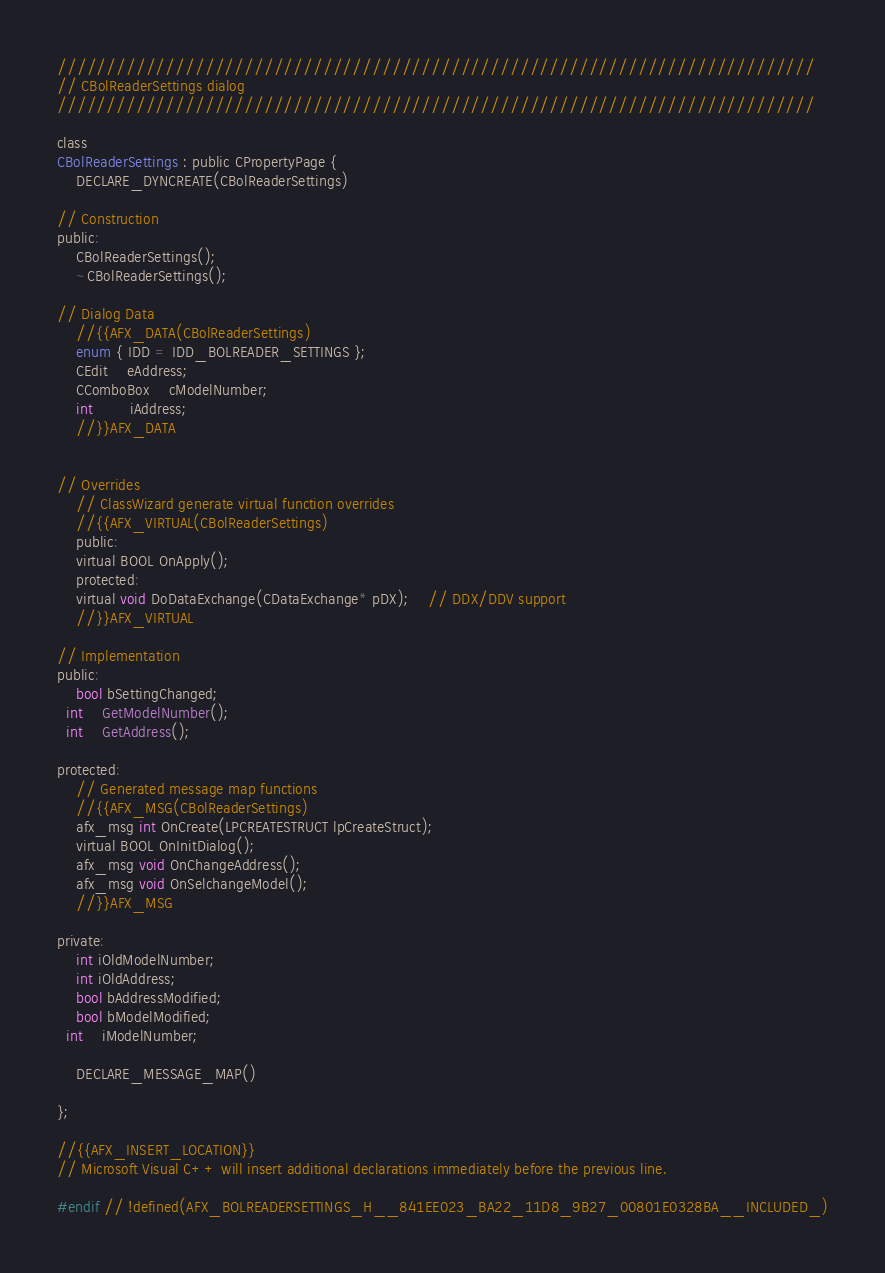Convert code to text. <code><loc_0><loc_0><loc_500><loc_500><_C_>/////////////////////////////////////////////////////////////////////////////
// CBolReaderSettings dialog
/////////////////////////////////////////////////////////////////////////////

class
CBolReaderSettings : public CPropertyPage {
	DECLARE_DYNCREATE(CBolReaderSettings)

// Construction
public:
	CBolReaderSettings();
	~CBolReaderSettings();

// Dialog Data
	//{{AFX_DATA(CBolReaderSettings)
	enum { IDD = IDD_BOLREADER_SETTINGS };
	CEdit	eAddress;
	CComboBox	cModelNumber;
	int		iAddress;
	//}}AFX_DATA


// Overrides
	// ClassWizard generate virtual function overrides
	//{{AFX_VIRTUAL(CBolReaderSettings)
	public:
	virtual BOOL OnApply();
	protected:
	virtual void DoDataExchange(CDataExchange* pDX);    // DDX/DDV support
	//}}AFX_VIRTUAL

// Implementation
public:
	bool bSettingChanged;
  int	GetModelNumber();
  int	GetAddress();

protected:
	// Generated message map functions
	//{{AFX_MSG(CBolReaderSettings)
	afx_msg int OnCreate(LPCREATESTRUCT lpCreateStruct);
	virtual BOOL OnInitDialog();
	afx_msg void OnChangeAddress();
	afx_msg void OnSelchangeModel();
	//}}AFX_MSG

private:
	int iOldModelNumber;
	int iOldAddress;
	bool bAddressModified;
	bool bModelModified;
  int	iModelNumber;

	DECLARE_MESSAGE_MAP()

};

//{{AFX_INSERT_LOCATION}}
// Microsoft Visual C++ will insert additional declarations immediately before the previous line.

#endif // !defined(AFX_BOLREADERSETTINGS_H__841EE023_BA22_11D8_9B27_00801E0328BA__INCLUDED_)
</code> 